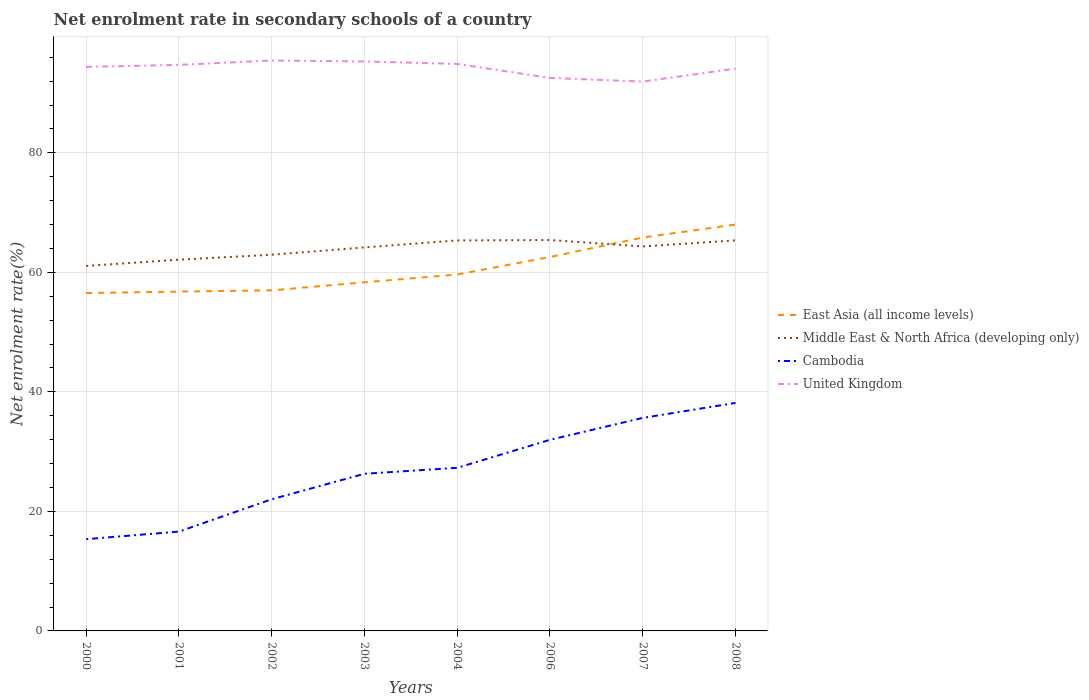How many different coloured lines are there?
Offer a terse response. 4. Across all years, what is the maximum net enrolment rate in secondary schools in Middle East & North Africa (developing only)?
Offer a terse response. 61.07. In which year was the net enrolment rate in secondary schools in Middle East & North Africa (developing only) maximum?
Keep it short and to the point. 2000. What is the total net enrolment rate in secondary schools in Middle East & North Africa (developing only) in the graph?
Provide a short and direct response. -3.24. What is the difference between the highest and the second highest net enrolment rate in secondary schools in Middle East & North Africa (developing only)?
Your response must be concise. 4.33. Is the net enrolment rate in secondary schools in Middle East & North Africa (developing only) strictly greater than the net enrolment rate in secondary schools in United Kingdom over the years?
Provide a short and direct response. Yes. Are the values on the major ticks of Y-axis written in scientific E-notation?
Your answer should be compact. No. Does the graph contain any zero values?
Your answer should be compact. No. Does the graph contain grids?
Your response must be concise. Yes. How many legend labels are there?
Offer a very short reply. 4. What is the title of the graph?
Keep it short and to the point. Net enrolment rate in secondary schools of a country. What is the label or title of the Y-axis?
Your response must be concise. Net enrolment rate(%). What is the Net enrolment rate(%) in East Asia (all income levels) in 2000?
Make the answer very short. 56.54. What is the Net enrolment rate(%) in Middle East & North Africa (developing only) in 2000?
Offer a terse response. 61.07. What is the Net enrolment rate(%) of Cambodia in 2000?
Make the answer very short. 15.36. What is the Net enrolment rate(%) in United Kingdom in 2000?
Make the answer very short. 94.38. What is the Net enrolment rate(%) in East Asia (all income levels) in 2001?
Provide a short and direct response. 56.78. What is the Net enrolment rate(%) of Middle East & North Africa (developing only) in 2001?
Your response must be concise. 62.12. What is the Net enrolment rate(%) in Cambodia in 2001?
Provide a short and direct response. 16.62. What is the Net enrolment rate(%) in United Kingdom in 2001?
Give a very brief answer. 94.72. What is the Net enrolment rate(%) of East Asia (all income levels) in 2002?
Make the answer very short. 56.99. What is the Net enrolment rate(%) of Middle East & North Africa (developing only) in 2002?
Make the answer very short. 62.95. What is the Net enrolment rate(%) in Cambodia in 2002?
Your answer should be compact. 22.03. What is the Net enrolment rate(%) of United Kingdom in 2002?
Offer a very short reply. 95.45. What is the Net enrolment rate(%) of East Asia (all income levels) in 2003?
Offer a terse response. 58.34. What is the Net enrolment rate(%) in Middle East & North Africa (developing only) in 2003?
Your answer should be compact. 64.17. What is the Net enrolment rate(%) of Cambodia in 2003?
Give a very brief answer. 26.3. What is the Net enrolment rate(%) of United Kingdom in 2003?
Your answer should be compact. 95.29. What is the Net enrolment rate(%) of East Asia (all income levels) in 2004?
Offer a terse response. 59.64. What is the Net enrolment rate(%) in Middle East & North Africa (developing only) in 2004?
Provide a succinct answer. 65.34. What is the Net enrolment rate(%) of Cambodia in 2004?
Your response must be concise. 27.29. What is the Net enrolment rate(%) in United Kingdom in 2004?
Give a very brief answer. 94.88. What is the Net enrolment rate(%) in East Asia (all income levels) in 2006?
Your answer should be compact. 62.57. What is the Net enrolment rate(%) of Middle East & North Africa (developing only) in 2006?
Provide a short and direct response. 65.41. What is the Net enrolment rate(%) in Cambodia in 2006?
Keep it short and to the point. 31.98. What is the Net enrolment rate(%) of United Kingdom in 2006?
Offer a terse response. 92.54. What is the Net enrolment rate(%) in East Asia (all income levels) in 2007?
Offer a very short reply. 65.83. What is the Net enrolment rate(%) in Middle East & North Africa (developing only) in 2007?
Your answer should be very brief. 64.34. What is the Net enrolment rate(%) of Cambodia in 2007?
Give a very brief answer. 35.65. What is the Net enrolment rate(%) in United Kingdom in 2007?
Provide a succinct answer. 91.92. What is the Net enrolment rate(%) in East Asia (all income levels) in 2008?
Keep it short and to the point. 68. What is the Net enrolment rate(%) of Middle East & North Africa (developing only) in 2008?
Offer a terse response. 65.36. What is the Net enrolment rate(%) in Cambodia in 2008?
Offer a terse response. 38.15. What is the Net enrolment rate(%) of United Kingdom in 2008?
Offer a terse response. 94.1. Across all years, what is the maximum Net enrolment rate(%) of East Asia (all income levels)?
Make the answer very short. 68. Across all years, what is the maximum Net enrolment rate(%) of Middle East & North Africa (developing only)?
Your answer should be very brief. 65.41. Across all years, what is the maximum Net enrolment rate(%) of Cambodia?
Keep it short and to the point. 38.15. Across all years, what is the maximum Net enrolment rate(%) of United Kingdom?
Your answer should be very brief. 95.45. Across all years, what is the minimum Net enrolment rate(%) of East Asia (all income levels)?
Keep it short and to the point. 56.54. Across all years, what is the minimum Net enrolment rate(%) in Middle East & North Africa (developing only)?
Offer a terse response. 61.07. Across all years, what is the minimum Net enrolment rate(%) of Cambodia?
Your response must be concise. 15.36. Across all years, what is the minimum Net enrolment rate(%) in United Kingdom?
Provide a short and direct response. 91.92. What is the total Net enrolment rate(%) in East Asia (all income levels) in the graph?
Offer a terse response. 484.7. What is the total Net enrolment rate(%) in Middle East & North Africa (developing only) in the graph?
Make the answer very short. 510.76. What is the total Net enrolment rate(%) in Cambodia in the graph?
Your answer should be very brief. 213.38. What is the total Net enrolment rate(%) of United Kingdom in the graph?
Offer a very short reply. 753.28. What is the difference between the Net enrolment rate(%) in East Asia (all income levels) in 2000 and that in 2001?
Your answer should be compact. -0.24. What is the difference between the Net enrolment rate(%) of Middle East & North Africa (developing only) in 2000 and that in 2001?
Provide a succinct answer. -1.04. What is the difference between the Net enrolment rate(%) of Cambodia in 2000 and that in 2001?
Offer a terse response. -1.27. What is the difference between the Net enrolment rate(%) of United Kingdom in 2000 and that in 2001?
Give a very brief answer. -0.34. What is the difference between the Net enrolment rate(%) in East Asia (all income levels) in 2000 and that in 2002?
Your response must be concise. -0.45. What is the difference between the Net enrolment rate(%) of Middle East & North Africa (developing only) in 2000 and that in 2002?
Offer a terse response. -1.88. What is the difference between the Net enrolment rate(%) of Cambodia in 2000 and that in 2002?
Ensure brevity in your answer.  -6.67. What is the difference between the Net enrolment rate(%) of United Kingdom in 2000 and that in 2002?
Make the answer very short. -1.07. What is the difference between the Net enrolment rate(%) of East Asia (all income levels) in 2000 and that in 2003?
Offer a very short reply. -1.8. What is the difference between the Net enrolment rate(%) of Middle East & North Africa (developing only) in 2000 and that in 2003?
Provide a succinct answer. -3.1. What is the difference between the Net enrolment rate(%) of Cambodia in 2000 and that in 2003?
Give a very brief answer. -10.94. What is the difference between the Net enrolment rate(%) of United Kingdom in 2000 and that in 2003?
Keep it short and to the point. -0.91. What is the difference between the Net enrolment rate(%) of East Asia (all income levels) in 2000 and that in 2004?
Provide a succinct answer. -3.1. What is the difference between the Net enrolment rate(%) of Middle East & North Africa (developing only) in 2000 and that in 2004?
Make the answer very short. -4.27. What is the difference between the Net enrolment rate(%) in Cambodia in 2000 and that in 2004?
Keep it short and to the point. -11.94. What is the difference between the Net enrolment rate(%) of United Kingdom in 2000 and that in 2004?
Provide a short and direct response. -0.5. What is the difference between the Net enrolment rate(%) of East Asia (all income levels) in 2000 and that in 2006?
Your answer should be compact. -6.03. What is the difference between the Net enrolment rate(%) of Middle East & North Africa (developing only) in 2000 and that in 2006?
Offer a very short reply. -4.33. What is the difference between the Net enrolment rate(%) of Cambodia in 2000 and that in 2006?
Ensure brevity in your answer.  -16.63. What is the difference between the Net enrolment rate(%) of United Kingdom in 2000 and that in 2006?
Give a very brief answer. 1.85. What is the difference between the Net enrolment rate(%) in East Asia (all income levels) in 2000 and that in 2007?
Provide a succinct answer. -9.29. What is the difference between the Net enrolment rate(%) of Middle East & North Africa (developing only) in 2000 and that in 2007?
Your response must be concise. -3.26. What is the difference between the Net enrolment rate(%) in Cambodia in 2000 and that in 2007?
Offer a terse response. -20.29. What is the difference between the Net enrolment rate(%) in United Kingdom in 2000 and that in 2007?
Give a very brief answer. 2.46. What is the difference between the Net enrolment rate(%) in East Asia (all income levels) in 2000 and that in 2008?
Give a very brief answer. -11.46. What is the difference between the Net enrolment rate(%) of Middle East & North Africa (developing only) in 2000 and that in 2008?
Your answer should be compact. -4.28. What is the difference between the Net enrolment rate(%) in Cambodia in 2000 and that in 2008?
Make the answer very short. -22.8. What is the difference between the Net enrolment rate(%) in United Kingdom in 2000 and that in 2008?
Keep it short and to the point. 0.28. What is the difference between the Net enrolment rate(%) in East Asia (all income levels) in 2001 and that in 2002?
Your answer should be compact. -0.21. What is the difference between the Net enrolment rate(%) in Middle East & North Africa (developing only) in 2001 and that in 2002?
Your response must be concise. -0.83. What is the difference between the Net enrolment rate(%) of Cambodia in 2001 and that in 2002?
Give a very brief answer. -5.41. What is the difference between the Net enrolment rate(%) in United Kingdom in 2001 and that in 2002?
Offer a terse response. -0.73. What is the difference between the Net enrolment rate(%) in East Asia (all income levels) in 2001 and that in 2003?
Your answer should be compact. -1.55. What is the difference between the Net enrolment rate(%) of Middle East & North Africa (developing only) in 2001 and that in 2003?
Give a very brief answer. -2.05. What is the difference between the Net enrolment rate(%) of Cambodia in 2001 and that in 2003?
Provide a succinct answer. -9.67. What is the difference between the Net enrolment rate(%) in United Kingdom in 2001 and that in 2003?
Your response must be concise. -0.58. What is the difference between the Net enrolment rate(%) of East Asia (all income levels) in 2001 and that in 2004?
Ensure brevity in your answer.  -2.86. What is the difference between the Net enrolment rate(%) in Middle East & North Africa (developing only) in 2001 and that in 2004?
Your answer should be compact. -3.22. What is the difference between the Net enrolment rate(%) in Cambodia in 2001 and that in 2004?
Offer a terse response. -10.67. What is the difference between the Net enrolment rate(%) of United Kingdom in 2001 and that in 2004?
Provide a short and direct response. -0.17. What is the difference between the Net enrolment rate(%) in East Asia (all income levels) in 2001 and that in 2006?
Your response must be concise. -5.79. What is the difference between the Net enrolment rate(%) in Middle East & North Africa (developing only) in 2001 and that in 2006?
Provide a short and direct response. -3.29. What is the difference between the Net enrolment rate(%) of Cambodia in 2001 and that in 2006?
Make the answer very short. -15.36. What is the difference between the Net enrolment rate(%) of United Kingdom in 2001 and that in 2006?
Make the answer very short. 2.18. What is the difference between the Net enrolment rate(%) of East Asia (all income levels) in 2001 and that in 2007?
Your answer should be compact. -9.05. What is the difference between the Net enrolment rate(%) of Middle East & North Africa (developing only) in 2001 and that in 2007?
Ensure brevity in your answer.  -2.22. What is the difference between the Net enrolment rate(%) of Cambodia in 2001 and that in 2007?
Your answer should be compact. -19.02. What is the difference between the Net enrolment rate(%) in United Kingdom in 2001 and that in 2007?
Provide a short and direct response. 2.8. What is the difference between the Net enrolment rate(%) of East Asia (all income levels) in 2001 and that in 2008?
Your answer should be very brief. -11.22. What is the difference between the Net enrolment rate(%) in Middle East & North Africa (developing only) in 2001 and that in 2008?
Give a very brief answer. -3.24. What is the difference between the Net enrolment rate(%) of Cambodia in 2001 and that in 2008?
Ensure brevity in your answer.  -21.53. What is the difference between the Net enrolment rate(%) in United Kingdom in 2001 and that in 2008?
Make the answer very short. 0.62. What is the difference between the Net enrolment rate(%) of East Asia (all income levels) in 2002 and that in 2003?
Your response must be concise. -1.35. What is the difference between the Net enrolment rate(%) in Middle East & North Africa (developing only) in 2002 and that in 2003?
Offer a terse response. -1.22. What is the difference between the Net enrolment rate(%) in Cambodia in 2002 and that in 2003?
Your response must be concise. -4.27. What is the difference between the Net enrolment rate(%) of United Kingdom in 2002 and that in 2003?
Provide a short and direct response. 0.16. What is the difference between the Net enrolment rate(%) of East Asia (all income levels) in 2002 and that in 2004?
Make the answer very short. -2.65. What is the difference between the Net enrolment rate(%) in Middle East & North Africa (developing only) in 2002 and that in 2004?
Give a very brief answer. -2.39. What is the difference between the Net enrolment rate(%) in Cambodia in 2002 and that in 2004?
Your response must be concise. -5.26. What is the difference between the Net enrolment rate(%) in United Kingdom in 2002 and that in 2004?
Make the answer very short. 0.57. What is the difference between the Net enrolment rate(%) of East Asia (all income levels) in 2002 and that in 2006?
Provide a short and direct response. -5.58. What is the difference between the Net enrolment rate(%) of Middle East & North Africa (developing only) in 2002 and that in 2006?
Give a very brief answer. -2.46. What is the difference between the Net enrolment rate(%) in Cambodia in 2002 and that in 2006?
Offer a very short reply. -9.95. What is the difference between the Net enrolment rate(%) in United Kingdom in 2002 and that in 2006?
Ensure brevity in your answer.  2.91. What is the difference between the Net enrolment rate(%) of East Asia (all income levels) in 2002 and that in 2007?
Offer a terse response. -8.84. What is the difference between the Net enrolment rate(%) of Middle East & North Africa (developing only) in 2002 and that in 2007?
Give a very brief answer. -1.38. What is the difference between the Net enrolment rate(%) in Cambodia in 2002 and that in 2007?
Keep it short and to the point. -13.62. What is the difference between the Net enrolment rate(%) of United Kingdom in 2002 and that in 2007?
Your answer should be compact. 3.53. What is the difference between the Net enrolment rate(%) in East Asia (all income levels) in 2002 and that in 2008?
Your answer should be very brief. -11.01. What is the difference between the Net enrolment rate(%) in Middle East & North Africa (developing only) in 2002 and that in 2008?
Give a very brief answer. -2.4. What is the difference between the Net enrolment rate(%) of Cambodia in 2002 and that in 2008?
Your response must be concise. -16.12. What is the difference between the Net enrolment rate(%) in United Kingdom in 2002 and that in 2008?
Your response must be concise. 1.35. What is the difference between the Net enrolment rate(%) of East Asia (all income levels) in 2003 and that in 2004?
Give a very brief answer. -1.3. What is the difference between the Net enrolment rate(%) of Middle East & North Africa (developing only) in 2003 and that in 2004?
Your answer should be very brief. -1.17. What is the difference between the Net enrolment rate(%) of Cambodia in 2003 and that in 2004?
Keep it short and to the point. -1. What is the difference between the Net enrolment rate(%) of United Kingdom in 2003 and that in 2004?
Your response must be concise. 0.41. What is the difference between the Net enrolment rate(%) in East Asia (all income levels) in 2003 and that in 2006?
Your answer should be very brief. -4.23. What is the difference between the Net enrolment rate(%) in Middle East & North Africa (developing only) in 2003 and that in 2006?
Your answer should be compact. -1.24. What is the difference between the Net enrolment rate(%) of Cambodia in 2003 and that in 2006?
Provide a succinct answer. -5.69. What is the difference between the Net enrolment rate(%) of United Kingdom in 2003 and that in 2006?
Your answer should be very brief. 2.76. What is the difference between the Net enrolment rate(%) in East Asia (all income levels) in 2003 and that in 2007?
Offer a terse response. -7.49. What is the difference between the Net enrolment rate(%) of Middle East & North Africa (developing only) in 2003 and that in 2007?
Your answer should be very brief. -0.16. What is the difference between the Net enrolment rate(%) in Cambodia in 2003 and that in 2007?
Provide a succinct answer. -9.35. What is the difference between the Net enrolment rate(%) of United Kingdom in 2003 and that in 2007?
Your answer should be compact. 3.37. What is the difference between the Net enrolment rate(%) in East Asia (all income levels) in 2003 and that in 2008?
Provide a short and direct response. -9.66. What is the difference between the Net enrolment rate(%) in Middle East & North Africa (developing only) in 2003 and that in 2008?
Ensure brevity in your answer.  -1.18. What is the difference between the Net enrolment rate(%) in Cambodia in 2003 and that in 2008?
Your answer should be compact. -11.86. What is the difference between the Net enrolment rate(%) in United Kingdom in 2003 and that in 2008?
Your answer should be very brief. 1.2. What is the difference between the Net enrolment rate(%) in East Asia (all income levels) in 2004 and that in 2006?
Make the answer very short. -2.93. What is the difference between the Net enrolment rate(%) in Middle East & North Africa (developing only) in 2004 and that in 2006?
Your answer should be very brief. -0.06. What is the difference between the Net enrolment rate(%) in Cambodia in 2004 and that in 2006?
Offer a very short reply. -4.69. What is the difference between the Net enrolment rate(%) in United Kingdom in 2004 and that in 2006?
Provide a short and direct response. 2.35. What is the difference between the Net enrolment rate(%) in East Asia (all income levels) in 2004 and that in 2007?
Provide a short and direct response. -6.19. What is the difference between the Net enrolment rate(%) of Middle East & North Africa (developing only) in 2004 and that in 2007?
Keep it short and to the point. 1.01. What is the difference between the Net enrolment rate(%) of Cambodia in 2004 and that in 2007?
Your answer should be compact. -8.35. What is the difference between the Net enrolment rate(%) in United Kingdom in 2004 and that in 2007?
Your answer should be compact. 2.96. What is the difference between the Net enrolment rate(%) of East Asia (all income levels) in 2004 and that in 2008?
Offer a very short reply. -8.36. What is the difference between the Net enrolment rate(%) of Middle East & North Africa (developing only) in 2004 and that in 2008?
Offer a very short reply. -0.01. What is the difference between the Net enrolment rate(%) in Cambodia in 2004 and that in 2008?
Give a very brief answer. -10.86. What is the difference between the Net enrolment rate(%) in United Kingdom in 2004 and that in 2008?
Provide a short and direct response. 0.79. What is the difference between the Net enrolment rate(%) in East Asia (all income levels) in 2006 and that in 2007?
Offer a very short reply. -3.26. What is the difference between the Net enrolment rate(%) in Middle East & North Africa (developing only) in 2006 and that in 2007?
Make the answer very short. 1.07. What is the difference between the Net enrolment rate(%) of Cambodia in 2006 and that in 2007?
Provide a short and direct response. -3.66. What is the difference between the Net enrolment rate(%) of United Kingdom in 2006 and that in 2007?
Provide a succinct answer. 0.62. What is the difference between the Net enrolment rate(%) of East Asia (all income levels) in 2006 and that in 2008?
Keep it short and to the point. -5.43. What is the difference between the Net enrolment rate(%) in Middle East & North Africa (developing only) in 2006 and that in 2008?
Offer a terse response. 0.05. What is the difference between the Net enrolment rate(%) in Cambodia in 2006 and that in 2008?
Offer a very short reply. -6.17. What is the difference between the Net enrolment rate(%) of United Kingdom in 2006 and that in 2008?
Offer a very short reply. -1.56. What is the difference between the Net enrolment rate(%) of East Asia (all income levels) in 2007 and that in 2008?
Provide a short and direct response. -2.17. What is the difference between the Net enrolment rate(%) in Middle East & North Africa (developing only) in 2007 and that in 2008?
Your answer should be compact. -1.02. What is the difference between the Net enrolment rate(%) in Cambodia in 2007 and that in 2008?
Your answer should be compact. -2.51. What is the difference between the Net enrolment rate(%) of United Kingdom in 2007 and that in 2008?
Make the answer very short. -2.18. What is the difference between the Net enrolment rate(%) of East Asia (all income levels) in 2000 and the Net enrolment rate(%) of Middle East & North Africa (developing only) in 2001?
Your answer should be compact. -5.58. What is the difference between the Net enrolment rate(%) in East Asia (all income levels) in 2000 and the Net enrolment rate(%) in Cambodia in 2001?
Make the answer very short. 39.92. What is the difference between the Net enrolment rate(%) of East Asia (all income levels) in 2000 and the Net enrolment rate(%) of United Kingdom in 2001?
Offer a very short reply. -38.18. What is the difference between the Net enrolment rate(%) in Middle East & North Africa (developing only) in 2000 and the Net enrolment rate(%) in Cambodia in 2001?
Your answer should be compact. 44.45. What is the difference between the Net enrolment rate(%) in Middle East & North Africa (developing only) in 2000 and the Net enrolment rate(%) in United Kingdom in 2001?
Make the answer very short. -33.64. What is the difference between the Net enrolment rate(%) in Cambodia in 2000 and the Net enrolment rate(%) in United Kingdom in 2001?
Make the answer very short. -79.36. What is the difference between the Net enrolment rate(%) in East Asia (all income levels) in 2000 and the Net enrolment rate(%) in Middle East & North Africa (developing only) in 2002?
Offer a terse response. -6.41. What is the difference between the Net enrolment rate(%) in East Asia (all income levels) in 2000 and the Net enrolment rate(%) in Cambodia in 2002?
Your response must be concise. 34.51. What is the difference between the Net enrolment rate(%) of East Asia (all income levels) in 2000 and the Net enrolment rate(%) of United Kingdom in 2002?
Give a very brief answer. -38.91. What is the difference between the Net enrolment rate(%) of Middle East & North Africa (developing only) in 2000 and the Net enrolment rate(%) of Cambodia in 2002?
Give a very brief answer. 39.04. What is the difference between the Net enrolment rate(%) of Middle East & North Africa (developing only) in 2000 and the Net enrolment rate(%) of United Kingdom in 2002?
Offer a very short reply. -34.38. What is the difference between the Net enrolment rate(%) of Cambodia in 2000 and the Net enrolment rate(%) of United Kingdom in 2002?
Your answer should be very brief. -80.09. What is the difference between the Net enrolment rate(%) in East Asia (all income levels) in 2000 and the Net enrolment rate(%) in Middle East & North Africa (developing only) in 2003?
Make the answer very short. -7.63. What is the difference between the Net enrolment rate(%) of East Asia (all income levels) in 2000 and the Net enrolment rate(%) of Cambodia in 2003?
Your answer should be very brief. 30.24. What is the difference between the Net enrolment rate(%) of East Asia (all income levels) in 2000 and the Net enrolment rate(%) of United Kingdom in 2003?
Provide a short and direct response. -38.75. What is the difference between the Net enrolment rate(%) in Middle East & North Africa (developing only) in 2000 and the Net enrolment rate(%) in Cambodia in 2003?
Make the answer very short. 34.78. What is the difference between the Net enrolment rate(%) of Middle East & North Africa (developing only) in 2000 and the Net enrolment rate(%) of United Kingdom in 2003?
Keep it short and to the point. -34.22. What is the difference between the Net enrolment rate(%) of Cambodia in 2000 and the Net enrolment rate(%) of United Kingdom in 2003?
Give a very brief answer. -79.94. What is the difference between the Net enrolment rate(%) in East Asia (all income levels) in 2000 and the Net enrolment rate(%) in Middle East & North Africa (developing only) in 2004?
Provide a short and direct response. -8.8. What is the difference between the Net enrolment rate(%) of East Asia (all income levels) in 2000 and the Net enrolment rate(%) of Cambodia in 2004?
Your answer should be very brief. 29.25. What is the difference between the Net enrolment rate(%) of East Asia (all income levels) in 2000 and the Net enrolment rate(%) of United Kingdom in 2004?
Offer a very short reply. -38.34. What is the difference between the Net enrolment rate(%) of Middle East & North Africa (developing only) in 2000 and the Net enrolment rate(%) of Cambodia in 2004?
Your answer should be very brief. 33.78. What is the difference between the Net enrolment rate(%) in Middle East & North Africa (developing only) in 2000 and the Net enrolment rate(%) in United Kingdom in 2004?
Your answer should be very brief. -33.81. What is the difference between the Net enrolment rate(%) of Cambodia in 2000 and the Net enrolment rate(%) of United Kingdom in 2004?
Make the answer very short. -79.53. What is the difference between the Net enrolment rate(%) in East Asia (all income levels) in 2000 and the Net enrolment rate(%) in Middle East & North Africa (developing only) in 2006?
Ensure brevity in your answer.  -8.87. What is the difference between the Net enrolment rate(%) in East Asia (all income levels) in 2000 and the Net enrolment rate(%) in Cambodia in 2006?
Your response must be concise. 24.56. What is the difference between the Net enrolment rate(%) of East Asia (all income levels) in 2000 and the Net enrolment rate(%) of United Kingdom in 2006?
Offer a very short reply. -36. What is the difference between the Net enrolment rate(%) of Middle East & North Africa (developing only) in 2000 and the Net enrolment rate(%) of Cambodia in 2006?
Offer a terse response. 29.09. What is the difference between the Net enrolment rate(%) of Middle East & North Africa (developing only) in 2000 and the Net enrolment rate(%) of United Kingdom in 2006?
Your response must be concise. -31.46. What is the difference between the Net enrolment rate(%) of Cambodia in 2000 and the Net enrolment rate(%) of United Kingdom in 2006?
Offer a very short reply. -77.18. What is the difference between the Net enrolment rate(%) of East Asia (all income levels) in 2000 and the Net enrolment rate(%) of Middle East & North Africa (developing only) in 2007?
Your answer should be very brief. -7.8. What is the difference between the Net enrolment rate(%) in East Asia (all income levels) in 2000 and the Net enrolment rate(%) in Cambodia in 2007?
Make the answer very short. 20.9. What is the difference between the Net enrolment rate(%) of East Asia (all income levels) in 2000 and the Net enrolment rate(%) of United Kingdom in 2007?
Ensure brevity in your answer.  -35.38. What is the difference between the Net enrolment rate(%) in Middle East & North Africa (developing only) in 2000 and the Net enrolment rate(%) in Cambodia in 2007?
Give a very brief answer. 25.43. What is the difference between the Net enrolment rate(%) of Middle East & North Africa (developing only) in 2000 and the Net enrolment rate(%) of United Kingdom in 2007?
Offer a very short reply. -30.85. What is the difference between the Net enrolment rate(%) of Cambodia in 2000 and the Net enrolment rate(%) of United Kingdom in 2007?
Keep it short and to the point. -76.56. What is the difference between the Net enrolment rate(%) of East Asia (all income levels) in 2000 and the Net enrolment rate(%) of Middle East & North Africa (developing only) in 2008?
Your answer should be compact. -8.81. What is the difference between the Net enrolment rate(%) of East Asia (all income levels) in 2000 and the Net enrolment rate(%) of Cambodia in 2008?
Your answer should be very brief. 18.39. What is the difference between the Net enrolment rate(%) of East Asia (all income levels) in 2000 and the Net enrolment rate(%) of United Kingdom in 2008?
Your answer should be compact. -37.56. What is the difference between the Net enrolment rate(%) in Middle East & North Africa (developing only) in 2000 and the Net enrolment rate(%) in Cambodia in 2008?
Offer a very short reply. 22.92. What is the difference between the Net enrolment rate(%) of Middle East & North Africa (developing only) in 2000 and the Net enrolment rate(%) of United Kingdom in 2008?
Provide a succinct answer. -33.02. What is the difference between the Net enrolment rate(%) in Cambodia in 2000 and the Net enrolment rate(%) in United Kingdom in 2008?
Offer a terse response. -78.74. What is the difference between the Net enrolment rate(%) of East Asia (all income levels) in 2001 and the Net enrolment rate(%) of Middle East & North Africa (developing only) in 2002?
Your answer should be compact. -6.17. What is the difference between the Net enrolment rate(%) of East Asia (all income levels) in 2001 and the Net enrolment rate(%) of Cambodia in 2002?
Ensure brevity in your answer.  34.75. What is the difference between the Net enrolment rate(%) in East Asia (all income levels) in 2001 and the Net enrolment rate(%) in United Kingdom in 2002?
Offer a terse response. -38.67. What is the difference between the Net enrolment rate(%) in Middle East & North Africa (developing only) in 2001 and the Net enrolment rate(%) in Cambodia in 2002?
Your answer should be compact. 40.09. What is the difference between the Net enrolment rate(%) of Middle East & North Africa (developing only) in 2001 and the Net enrolment rate(%) of United Kingdom in 2002?
Provide a succinct answer. -33.33. What is the difference between the Net enrolment rate(%) of Cambodia in 2001 and the Net enrolment rate(%) of United Kingdom in 2002?
Offer a very short reply. -78.83. What is the difference between the Net enrolment rate(%) in East Asia (all income levels) in 2001 and the Net enrolment rate(%) in Middle East & North Africa (developing only) in 2003?
Offer a very short reply. -7.39. What is the difference between the Net enrolment rate(%) in East Asia (all income levels) in 2001 and the Net enrolment rate(%) in Cambodia in 2003?
Ensure brevity in your answer.  30.49. What is the difference between the Net enrolment rate(%) in East Asia (all income levels) in 2001 and the Net enrolment rate(%) in United Kingdom in 2003?
Provide a short and direct response. -38.51. What is the difference between the Net enrolment rate(%) of Middle East & North Africa (developing only) in 2001 and the Net enrolment rate(%) of Cambodia in 2003?
Make the answer very short. 35.82. What is the difference between the Net enrolment rate(%) in Middle East & North Africa (developing only) in 2001 and the Net enrolment rate(%) in United Kingdom in 2003?
Offer a terse response. -33.17. What is the difference between the Net enrolment rate(%) of Cambodia in 2001 and the Net enrolment rate(%) of United Kingdom in 2003?
Your answer should be very brief. -78.67. What is the difference between the Net enrolment rate(%) of East Asia (all income levels) in 2001 and the Net enrolment rate(%) of Middle East & North Africa (developing only) in 2004?
Give a very brief answer. -8.56. What is the difference between the Net enrolment rate(%) of East Asia (all income levels) in 2001 and the Net enrolment rate(%) of Cambodia in 2004?
Your answer should be compact. 29.49. What is the difference between the Net enrolment rate(%) of East Asia (all income levels) in 2001 and the Net enrolment rate(%) of United Kingdom in 2004?
Offer a very short reply. -38.1. What is the difference between the Net enrolment rate(%) in Middle East & North Africa (developing only) in 2001 and the Net enrolment rate(%) in Cambodia in 2004?
Provide a short and direct response. 34.82. What is the difference between the Net enrolment rate(%) of Middle East & North Africa (developing only) in 2001 and the Net enrolment rate(%) of United Kingdom in 2004?
Ensure brevity in your answer.  -32.76. What is the difference between the Net enrolment rate(%) of Cambodia in 2001 and the Net enrolment rate(%) of United Kingdom in 2004?
Give a very brief answer. -78.26. What is the difference between the Net enrolment rate(%) of East Asia (all income levels) in 2001 and the Net enrolment rate(%) of Middle East & North Africa (developing only) in 2006?
Your response must be concise. -8.63. What is the difference between the Net enrolment rate(%) in East Asia (all income levels) in 2001 and the Net enrolment rate(%) in Cambodia in 2006?
Offer a very short reply. 24.8. What is the difference between the Net enrolment rate(%) in East Asia (all income levels) in 2001 and the Net enrolment rate(%) in United Kingdom in 2006?
Your answer should be compact. -35.76. What is the difference between the Net enrolment rate(%) in Middle East & North Africa (developing only) in 2001 and the Net enrolment rate(%) in Cambodia in 2006?
Ensure brevity in your answer.  30.14. What is the difference between the Net enrolment rate(%) of Middle East & North Africa (developing only) in 2001 and the Net enrolment rate(%) of United Kingdom in 2006?
Provide a short and direct response. -30.42. What is the difference between the Net enrolment rate(%) of Cambodia in 2001 and the Net enrolment rate(%) of United Kingdom in 2006?
Your response must be concise. -75.91. What is the difference between the Net enrolment rate(%) in East Asia (all income levels) in 2001 and the Net enrolment rate(%) in Middle East & North Africa (developing only) in 2007?
Provide a short and direct response. -7.55. What is the difference between the Net enrolment rate(%) in East Asia (all income levels) in 2001 and the Net enrolment rate(%) in Cambodia in 2007?
Offer a very short reply. 21.14. What is the difference between the Net enrolment rate(%) of East Asia (all income levels) in 2001 and the Net enrolment rate(%) of United Kingdom in 2007?
Offer a very short reply. -35.14. What is the difference between the Net enrolment rate(%) in Middle East & North Africa (developing only) in 2001 and the Net enrolment rate(%) in Cambodia in 2007?
Give a very brief answer. 26.47. What is the difference between the Net enrolment rate(%) of Middle East & North Africa (developing only) in 2001 and the Net enrolment rate(%) of United Kingdom in 2007?
Ensure brevity in your answer.  -29.8. What is the difference between the Net enrolment rate(%) of Cambodia in 2001 and the Net enrolment rate(%) of United Kingdom in 2007?
Your answer should be compact. -75.3. What is the difference between the Net enrolment rate(%) of East Asia (all income levels) in 2001 and the Net enrolment rate(%) of Middle East & North Africa (developing only) in 2008?
Make the answer very short. -8.57. What is the difference between the Net enrolment rate(%) of East Asia (all income levels) in 2001 and the Net enrolment rate(%) of Cambodia in 2008?
Your answer should be very brief. 18.63. What is the difference between the Net enrolment rate(%) of East Asia (all income levels) in 2001 and the Net enrolment rate(%) of United Kingdom in 2008?
Offer a very short reply. -37.32. What is the difference between the Net enrolment rate(%) of Middle East & North Africa (developing only) in 2001 and the Net enrolment rate(%) of Cambodia in 2008?
Give a very brief answer. 23.97. What is the difference between the Net enrolment rate(%) in Middle East & North Africa (developing only) in 2001 and the Net enrolment rate(%) in United Kingdom in 2008?
Provide a succinct answer. -31.98. What is the difference between the Net enrolment rate(%) in Cambodia in 2001 and the Net enrolment rate(%) in United Kingdom in 2008?
Provide a succinct answer. -77.48. What is the difference between the Net enrolment rate(%) in East Asia (all income levels) in 2002 and the Net enrolment rate(%) in Middle East & North Africa (developing only) in 2003?
Offer a very short reply. -7.18. What is the difference between the Net enrolment rate(%) of East Asia (all income levels) in 2002 and the Net enrolment rate(%) of Cambodia in 2003?
Provide a succinct answer. 30.69. What is the difference between the Net enrolment rate(%) of East Asia (all income levels) in 2002 and the Net enrolment rate(%) of United Kingdom in 2003?
Your answer should be very brief. -38.3. What is the difference between the Net enrolment rate(%) of Middle East & North Africa (developing only) in 2002 and the Net enrolment rate(%) of Cambodia in 2003?
Give a very brief answer. 36.66. What is the difference between the Net enrolment rate(%) in Middle East & North Africa (developing only) in 2002 and the Net enrolment rate(%) in United Kingdom in 2003?
Your response must be concise. -32.34. What is the difference between the Net enrolment rate(%) in Cambodia in 2002 and the Net enrolment rate(%) in United Kingdom in 2003?
Provide a short and direct response. -73.26. What is the difference between the Net enrolment rate(%) in East Asia (all income levels) in 2002 and the Net enrolment rate(%) in Middle East & North Africa (developing only) in 2004?
Your response must be concise. -8.35. What is the difference between the Net enrolment rate(%) of East Asia (all income levels) in 2002 and the Net enrolment rate(%) of Cambodia in 2004?
Your response must be concise. 29.7. What is the difference between the Net enrolment rate(%) of East Asia (all income levels) in 2002 and the Net enrolment rate(%) of United Kingdom in 2004?
Offer a terse response. -37.89. What is the difference between the Net enrolment rate(%) in Middle East & North Africa (developing only) in 2002 and the Net enrolment rate(%) in Cambodia in 2004?
Offer a very short reply. 35.66. What is the difference between the Net enrolment rate(%) in Middle East & North Africa (developing only) in 2002 and the Net enrolment rate(%) in United Kingdom in 2004?
Your answer should be very brief. -31.93. What is the difference between the Net enrolment rate(%) in Cambodia in 2002 and the Net enrolment rate(%) in United Kingdom in 2004?
Your answer should be compact. -72.85. What is the difference between the Net enrolment rate(%) of East Asia (all income levels) in 2002 and the Net enrolment rate(%) of Middle East & North Africa (developing only) in 2006?
Your response must be concise. -8.42. What is the difference between the Net enrolment rate(%) in East Asia (all income levels) in 2002 and the Net enrolment rate(%) in Cambodia in 2006?
Your answer should be compact. 25.01. What is the difference between the Net enrolment rate(%) of East Asia (all income levels) in 2002 and the Net enrolment rate(%) of United Kingdom in 2006?
Your response must be concise. -35.55. What is the difference between the Net enrolment rate(%) in Middle East & North Africa (developing only) in 2002 and the Net enrolment rate(%) in Cambodia in 2006?
Ensure brevity in your answer.  30.97. What is the difference between the Net enrolment rate(%) of Middle East & North Africa (developing only) in 2002 and the Net enrolment rate(%) of United Kingdom in 2006?
Keep it short and to the point. -29.58. What is the difference between the Net enrolment rate(%) in Cambodia in 2002 and the Net enrolment rate(%) in United Kingdom in 2006?
Your answer should be very brief. -70.51. What is the difference between the Net enrolment rate(%) of East Asia (all income levels) in 2002 and the Net enrolment rate(%) of Middle East & North Africa (developing only) in 2007?
Ensure brevity in your answer.  -7.35. What is the difference between the Net enrolment rate(%) in East Asia (all income levels) in 2002 and the Net enrolment rate(%) in Cambodia in 2007?
Give a very brief answer. 21.34. What is the difference between the Net enrolment rate(%) in East Asia (all income levels) in 2002 and the Net enrolment rate(%) in United Kingdom in 2007?
Your response must be concise. -34.93. What is the difference between the Net enrolment rate(%) in Middle East & North Africa (developing only) in 2002 and the Net enrolment rate(%) in Cambodia in 2007?
Your response must be concise. 27.31. What is the difference between the Net enrolment rate(%) in Middle East & North Africa (developing only) in 2002 and the Net enrolment rate(%) in United Kingdom in 2007?
Give a very brief answer. -28.97. What is the difference between the Net enrolment rate(%) of Cambodia in 2002 and the Net enrolment rate(%) of United Kingdom in 2007?
Provide a succinct answer. -69.89. What is the difference between the Net enrolment rate(%) of East Asia (all income levels) in 2002 and the Net enrolment rate(%) of Middle East & North Africa (developing only) in 2008?
Your answer should be very brief. -8.37. What is the difference between the Net enrolment rate(%) of East Asia (all income levels) in 2002 and the Net enrolment rate(%) of Cambodia in 2008?
Provide a short and direct response. 18.84. What is the difference between the Net enrolment rate(%) of East Asia (all income levels) in 2002 and the Net enrolment rate(%) of United Kingdom in 2008?
Give a very brief answer. -37.11. What is the difference between the Net enrolment rate(%) of Middle East & North Africa (developing only) in 2002 and the Net enrolment rate(%) of Cambodia in 2008?
Make the answer very short. 24.8. What is the difference between the Net enrolment rate(%) in Middle East & North Africa (developing only) in 2002 and the Net enrolment rate(%) in United Kingdom in 2008?
Ensure brevity in your answer.  -31.15. What is the difference between the Net enrolment rate(%) in Cambodia in 2002 and the Net enrolment rate(%) in United Kingdom in 2008?
Keep it short and to the point. -72.07. What is the difference between the Net enrolment rate(%) of East Asia (all income levels) in 2003 and the Net enrolment rate(%) of Middle East & North Africa (developing only) in 2004?
Provide a short and direct response. -7.01. What is the difference between the Net enrolment rate(%) of East Asia (all income levels) in 2003 and the Net enrolment rate(%) of Cambodia in 2004?
Provide a short and direct response. 31.04. What is the difference between the Net enrolment rate(%) in East Asia (all income levels) in 2003 and the Net enrolment rate(%) in United Kingdom in 2004?
Provide a succinct answer. -36.55. What is the difference between the Net enrolment rate(%) in Middle East & North Africa (developing only) in 2003 and the Net enrolment rate(%) in Cambodia in 2004?
Offer a very short reply. 36.88. What is the difference between the Net enrolment rate(%) in Middle East & North Africa (developing only) in 2003 and the Net enrolment rate(%) in United Kingdom in 2004?
Give a very brief answer. -30.71. What is the difference between the Net enrolment rate(%) in Cambodia in 2003 and the Net enrolment rate(%) in United Kingdom in 2004?
Your answer should be very brief. -68.59. What is the difference between the Net enrolment rate(%) of East Asia (all income levels) in 2003 and the Net enrolment rate(%) of Middle East & North Africa (developing only) in 2006?
Your response must be concise. -7.07. What is the difference between the Net enrolment rate(%) of East Asia (all income levels) in 2003 and the Net enrolment rate(%) of Cambodia in 2006?
Offer a very short reply. 26.36. What is the difference between the Net enrolment rate(%) in East Asia (all income levels) in 2003 and the Net enrolment rate(%) in United Kingdom in 2006?
Your answer should be compact. -34.2. What is the difference between the Net enrolment rate(%) in Middle East & North Africa (developing only) in 2003 and the Net enrolment rate(%) in Cambodia in 2006?
Offer a very short reply. 32.19. What is the difference between the Net enrolment rate(%) of Middle East & North Africa (developing only) in 2003 and the Net enrolment rate(%) of United Kingdom in 2006?
Provide a short and direct response. -28.36. What is the difference between the Net enrolment rate(%) of Cambodia in 2003 and the Net enrolment rate(%) of United Kingdom in 2006?
Provide a short and direct response. -66.24. What is the difference between the Net enrolment rate(%) in East Asia (all income levels) in 2003 and the Net enrolment rate(%) in Middle East & North Africa (developing only) in 2007?
Your response must be concise. -6. What is the difference between the Net enrolment rate(%) in East Asia (all income levels) in 2003 and the Net enrolment rate(%) in Cambodia in 2007?
Provide a short and direct response. 22.69. What is the difference between the Net enrolment rate(%) of East Asia (all income levels) in 2003 and the Net enrolment rate(%) of United Kingdom in 2007?
Provide a short and direct response. -33.58. What is the difference between the Net enrolment rate(%) in Middle East & North Africa (developing only) in 2003 and the Net enrolment rate(%) in Cambodia in 2007?
Your response must be concise. 28.53. What is the difference between the Net enrolment rate(%) in Middle East & North Africa (developing only) in 2003 and the Net enrolment rate(%) in United Kingdom in 2007?
Provide a succinct answer. -27.75. What is the difference between the Net enrolment rate(%) of Cambodia in 2003 and the Net enrolment rate(%) of United Kingdom in 2007?
Give a very brief answer. -65.62. What is the difference between the Net enrolment rate(%) in East Asia (all income levels) in 2003 and the Net enrolment rate(%) in Middle East & North Africa (developing only) in 2008?
Give a very brief answer. -7.02. What is the difference between the Net enrolment rate(%) of East Asia (all income levels) in 2003 and the Net enrolment rate(%) of Cambodia in 2008?
Provide a succinct answer. 20.18. What is the difference between the Net enrolment rate(%) of East Asia (all income levels) in 2003 and the Net enrolment rate(%) of United Kingdom in 2008?
Make the answer very short. -35.76. What is the difference between the Net enrolment rate(%) in Middle East & North Africa (developing only) in 2003 and the Net enrolment rate(%) in Cambodia in 2008?
Offer a terse response. 26.02. What is the difference between the Net enrolment rate(%) in Middle East & North Africa (developing only) in 2003 and the Net enrolment rate(%) in United Kingdom in 2008?
Keep it short and to the point. -29.93. What is the difference between the Net enrolment rate(%) in Cambodia in 2003 and the Net enrolment rate(%) in United Kingdom in 2008?
Ensure brevity in your answer.  -67.8. What is the difference between the Net enrolment rate(%) of East Asia (all income levels) in 2004 and the Net enrolment rate(%) of Middle East & North Africa (developing only) in 2006?
Your response must be concise. -5.77. What is the difference between the Net enrolment rate(%) of East Asia (all income levels) in 2004 and the Net enrolment rate(%) of Cambodia in 2006?
Give a very brief answer. 27.66. What is the difference between the Net enrolment rate(%) of East Asia (all income levels) in 2004 and the Net enrolment rate(%) of United Kingdom in 2006?
Keep it short and to the point. -32.9. What is the difference between the Net enrolment rate(%) in Middle East & North Africa (developing only) in 2004 and the Net enrolment rate(%) in Cambodia in 2006?
Provide a succinct answer. 33.36. What is the difference between the Net enrolment rate(%) in Middle East & North Africa (developing only) in 2004 and the Net enrolment rate(%) in United Kingdom in 2006?
Your answer should be very brief. -27.19. What is the difference between the Net enrolment rate(%) in Cambodia in 2004 and the Net enrolment rate(%) in United Kingdom in 2006?
Provide a succinct answer. -65.24. What is the difference between the Net enrolment rate(%) in East Asia (all income levels) in 2004 and the Net enrolment rate(%) in Middle East & North Africa (developing only) in 2007?
Offer a very short reply. -4.7. What is the difference between the Net enrolment rate(%) in East Asia (all income levels) in 2004 and the Net enrolment rate(%) in Cambodia in 2007?
Keep it short and to the point. 23.99. What is the difference between the Net enrolment rate(%) of East Asia (all income levels) in 2004 and the Net enrolment rate(%) of United Kingdom in 2007?
Your answer should be compact. -32.28. What is the difference between the Net enrolment rate(%) of Middle East & North Africa (developing only) in 2004 and the Net enrolment rate(%) of Cambodia in 2007?
Ensure brevity in your answer.  29.7. What is the difference between the Net enrolment rate(%) of Middle East & North Africa (developing only) in 2004 and the Net enrolment rate(%) of United Kingdom in 2007?
Provide a short and direct response. -26.58. What is the difference between the Net enrolment rate(%) of Cambodia in 2004 and the Net enrolment rate(%) of United Kingdom in 2007?
Give a very brief answer. -64.63. What is the difference between the Net enrolment rate(%) of East Asia (all income levels) in 2004 and the Net enrolment rate(%) of Middle East & North Africa (developing only) in 2008?
Offer a terse response. -5.72. What is the difference between the Net enrolment rate(%) of East Asia (all income levels) in 2004 and the Net enrolment rate(%) of Cambodia in 2008?
Make the answer very short. 21.49. What is the difference between the Net enrolment rate(%) in East Asia (all income levels) in 2004 and the Net enrolment rate(%) in United Kingdom in 2008?
Your answer should be very brief. -34.46. What is the difference between the Net enrolment rate(%) of Middle East & North Africa (developing only) in 2004 and the Net enrolment rate(%) of Cambodia in 2008?
Keep it short and to the point. 27.19. What is the difference between the Net enrolment rate(%) of Middle East & North Africa (developing only) in 2004 and the Net enrolment rate(%) of United Kingdom in 2008?
Your response must be concise. -28.75. What is the difference between the Net enrolment rate(%) of Cambodia in 2004 and the Net enrolment rate(%) of United Kingdom in 2008?
Give a very brief answer. -66.8. What is the difference between the Net enrolment rate(%) of East Asia (all income levels) in 2006 and the Net enrolment rate(%) of Middle East & North Africa (developing only) in 2007?
Give a very brief answer. -1.76. What is the difference between the Net enrolment rate(%) in East Asia (all income levels) in 2006 and the Net enrolment rate(%) in Cambodia in 2007?
Your answer should be compact. 26.93. What is the difference between the Net enrolment rate(%) of East Asia (all income levels) in 2006 and the Net enrolment rate(%) of United Kingdom in 2007?
Your answer should be compact. -29.35. What is the difference between the Net enrolment rate(%) in Middle East & North Africa (developing only) in 2006 and the Net enrolment rate(%) in Cambodia in 2007?
Provide a succinct answer. 29.76. What is the difference between the Net enrolment rate(%) in Middle East & North Africa (developing only) in 2006 and the Net enrolment rate(%) in United Kingdom in 2007?
Ensure brevity in your answer.  -26.51. What is the difference between the Net enrolment rate(%) of Cambodia in 2006 and the Net enrolment rate(%) of United Kingdom in 2007?
Provide a succinct answer. -59.94. What is the difference between the Net enrolment rate(%) in East Asia (all income levels) in 2006 and the Net enrolment rate(%) in Middle East & North Africa (developing only) in 2008?
Provide a succinct answer. -2.78. What is the difference between the Net enrolment rate(%) of East Asia (all income levels) in 2006 and the Net enrolment rate(%) of Cambodia in 2008?
Give a very brief answer. 24.42. What is the difference between the Net enrolment rate(%) in East Asia (all income levels) in 2006 and the Net enrolment rate(%) in United Kingdom in 2008?
Offer a very short reply. -31.53. What is the difference between the Net enrolment rate(%) in Middle East & North Africa (developing only) in 2006 and the Net enrolment rate(%) in Cambodia in 2008?
Keep it short and to the point. 27.25. What is the difference between the Net enrolment rate(%) of Middle East & North Africa (developing only) in 2006 and the Net enrolment rate(%) of United Kingdom in 2008?
Your answer should be very brief. -28.69. What is the difference between the Net enrolment rate(%) of Cambodia in 2006 and the Net enrolment rate(%) of United Kingdom in 2008?
Keep it short and to the point. -62.12. What is the difference between the Net enrolment rate(%) of East Asia (all income levels) in 2007 and the Net enrolment rate(%) of Middle East & North Africa (developing only) in 2008?
Keep it short and to the point. 0.48. What is the difference between the Net enrolment rate(%) of East Asia (all income levels) in 2007 and the Net enrolment rate(%) of Cambodia in 2008?
Ensure brevity in your answer.  27.68. What is the difference between the Net enrolment rate(%) in East Asia (all income levels) in 2007 and the Net enrolment rate(%) in United Kingdom in 2008?
Provide a short and direct response. -28.27. What is the difference between the Net enrolment rate(%) of Middle East & North Africa (developing only) in 2007 and the Net enrolment rate(%) of Cambodia in 2008?
Keep it short and to the point. 26.18. What is the difference between the Net enrolment rate(%) in Middle East & North Africa (developing only) in 2007 and the Net enrolment rate(%) in United Kingdom in 2008?
Give a very brief answer. -29.76. What is the difference between the Net enrolment rate(%) in Cambodia in 2007 and the Net enrolment rate(%) in United Kingdom in 2008?
Your answer should be compact. -58.45. What is the average Net enrolment rate(%) of East Asia (all income levels) per year?
Your answer should be very brief. 60.59. What is the average Net enrolment rate(%) of Middle East & North Africa (developing only) per year?
Your response must be concise. 63.85. What is the average Net enrolment rate(%) in Cambodia per year?
Provide a short and direct response. 26.67. What is the average Net enrolment rate(%) in United Kingdom per year?
Keep it short and to the point. 94.16. In the year 2000, what is the difference between the Net enrolment rate(%) of East Asia (all income levels) and Net enrolment rate(%) of Middle East & North Africa (developing only)?
Provide a succinct answer. -4.53. In the year 2000, what is the difference between the Net enrolment rate(%) in East Asia (all income levels) and Net enrolment rate(%) in Cambodia?
Offer a very short reply. 41.19. In the year 2000, what is the difference between the Net enrolment rate(%) of East Asia (all income levels) and Net enrolment rate(%) of United Kingdom?
Offer a very short reply. -37.84. In the year 2000, what is the difference between the Net enrolment rate(%) in Middle East & North Africa (developing only) and Net enrolment rate(%) in Cambodia?
Make the answer very short. 45.72. In the year 2000, what is the difference between the Net enrolment rate(%) of Middle East & North Africa (developing only) and Net enrolment rate(%) of United Kingdom?
Your answer should be very brief. -33.31. In the year 2000, what is the difference between the Net enrolment rate(%) in Cambodia and Net enrolment rate(%) in United Kingdom?
Offer a very short reply. -79.03. In the year 2001, what is the difference between the Net enrolment rate(%) in East Asia (all income levels) and Net enrolment rate(%) in Middle East & North Africa (developing only)?
Your answer should be compact. -5.34. In the year 2001, what is the difference between the Net enrolment rate(%) of East Asia (all income levels) and Net enrolment rate(%) of Cambodia?
Offer a terse response. 40.16. In the year 2001, what is the difference between the Net enrolment rate(%) in East Asia (all income levels) and Net enrolment rate(%) in United Kingdom?
Provide a succinct answer. -37.94. In the year 2001, what is the difference between the Net enrolment rate(%) in Middle East & North Africa (developing only) and Net enrolment rate(%) in Cambodia?
Provide a short and direct response. 45.5. In the year 2001, what is the difference between the Net enrolment rate(%) of Middle East & North Africa (developing only) and Net enrolment rate(%) of United Kingdom?
Give a very brief answer. -32.6. In the year 2001, what is the difference between the Net enrolment rate(%) in Cambodia and Net enrolment rate(%) in United Kingdom?
Provide a short and direct response. -78.09. In the year 2002, what is the difference between the Net enrolment rate(%) in East Asia (all income levels) and Net enrolment rate(%) in Middle East & North Africa (developing only)?
Ensure brevity in your answer.  -5.96. In the year 2002, what is the difference between the Net enrolment rate(%) of East Asia (all income levels) and Net enrolment rate(%) of Cambodia?
Your answer should be compact. 34.96. In the year 2002, what is the difference between the Net enrolment rate(%) in East Asia (all income levels) and Net enrolment rate(%) in United Kingdom?
Your answer should be compact. -38.46. In the year 2002, what is the difference between the Net enrolment rate(%) in Middle East & North Africa (developing only) and Net enrolment rate(%) in Cambodia?
Offer a very short reply. 40.92. In the year 2002, what is the difference between the Net enrolment rate(%) in Middle East & North Africa (developing only) and Net enrolment rate(%) in United Kingdom?
Provide a short and direct response. -32.5. In the year 2002, what is the difference between the Net enrolment rate(%) of Cambodia and Net enrolment rate(%) of United Kingdom?
Ensure brevity in your answer.  -73.42. In the year 2003, what is the difference between the Net enrolment rate(%) in East Asia (all income levels) and Net enrolment rate(%) in Middle East & North Africa (developing only)?
Give a very brief answer. -5.84. In the year 2003, what is the difference between the Net enrolment rate(%) in East Asia (all income levels) and Net enrolment rate(%) in Cambodia?
Your response must be concise. 32.04. In the year 2003, what is the difference between the Net enrolment rate(%) of East Asia (all income levels) and Net enrolment rate(%) of United Kingdom?
Provide a succinct answer. -36.96. In the year 2003, what is the difference between the Net enrolment rate(%) of Middle East & North Africa (developing only) and Net enrolment rate(%) of Cambodia?
Your answer should be very brief. 37.88. In the year 2003, what is the difference between the Net enrolment rate(%) in Middle East & North Africa (developing only) and Net enrolment rate(%) in United Kingdom?
Provide a short and direct response. -31.12. In the year 2003, what is the difference between the Net enrolment rate(%) in Cambodia and Net enrolment rate(%) in United Kingdom?
Ensure brevity in your answer.  -69. In the year 2004, what is the difference between the Net enrolment rate(%) of East Asia (all income levels) and Net enrolment rate(%) of Middle East & North Africa (developing only)?
Your answer should be compact. -5.7. In the year 2004, what is the difference between the Net enrolment rate(%) of East Asia (all income levels) and Net enrolment rate(%) of Cambodia?
Give a very brief answer. 32.35. In the year 2004, what is the difference between the Net enrolment rate(%) in East Asia (all income levels) and Net enrolment rate(%) in United Kingdom?
Ensure brevity in your answer.  -35.24. In the year 2004, what is the difference between the Net enrolment rate(%) in Middle East & North Africa (developing only) and Net enrolment rate(%) in Cambodia?
Provide a short and direct response. 38.05. In the year 2004, what is the difference between the Net enrolment rate(%) of Middle East & North Africa (developing only) and Net enrolment rate(%) of United Kingdom?
Ensure brevity in your answer.  -29.54. In the year 2004, what is the difference between the Net enrolment rate(%) in Cambodia and Net enrolment rate(%) in United Kingdom?
Make the answer very short. -67.59. In the year 2006, what is the difference between the Net enrolment rate(%) of East Asia (all income levels) and Net enrolment rate(%) of Middle East & North Africa (developing only)?
Your answer should be compact. -2.84. In the year 2006, what is the difference between the Net enrolment rate(%) of East Asia (all income levels) and Net enrolment rate(%) of Cambodia?
Ensure brevity in your answer.  30.59. In the year 2006, what is the difference between the Net enrolment rate(%) in East Asia (all income levels) and Net enrolment rate(%) in United Kingdom?
Provide a succinct answer. -29.97. In the year 2006, what is the difference between the Net enrolment rate(%) of Middle East & North Africa (developing only) and Net enrolment rate(%) of Cambodia?
Provide a succinct answer. 33.43. In the year 2006, what is the difference between the Net enrolment rate(%) of Middle East & North Africa (developing only) and Net enrolment rate(%) of United Kingdom?
Ensure brevity in your answer.  -27.13. In the year 2006, what is the difference between the Net enrolment rate(%) in Cambodia and Net enrolment rate(%) in United Kingdom?
Provide a succinct answer. -60.56. In the year 2007, what is the difference between the Net enrolment rate(%) in East Asia (all income levels) and Net enrolment rate(%) in Middle East & North Africa (developing only)?
Offer a very short reply. 1.5. In the year 2007, what is the difference between the Net enrolment rate(%) in East Asia (all income levels) and Net enrolment rate(%) in Cambodia?
Your answer should be very brief. 30.19. In the year 2007, what is the difference between the Net enrolment rate(%) of East Asia (all income levels) and Net enrolment rate(%) of United Kingdom?
Your answer should be very brief. -26.09. In the year 2007, what is the difference between the Net enrolment rate(%) in Middle East & North Africa (developing only) and Net enrolment rate(%) in Cambodia?
Your response must be concise. 28.69. In the year 2007, what is the difference between the Net enrolment rate(%) in Middle East & North Africa (developing only) and Net enrolment rate(%) in United Kingdom?
Give a very brief answer. -27.58. In the year 2007, what is the difference between the Net enrolment rate(%) in Cambodia and Net enrolment rate(%) in United Kingdom?
Ensure brevity in your answer.  -56.28. In the year 2008, what is the difference between the Net enrolment rate(%) in East Asia (all income levels) and Net enrolment rate(%) in Middle East & North Africa (developing only)?
Provide a short and direct response. 2.65. In the year 2008, what is the difference between the Net enrolment rate(%) of East Asia (all income levels) and Net enrolment rate(%) of Cambodia?
Offer a very short reply. 29.85. In the year 2008, what is the difference between the Net enrolment rate(%) of East Asia (all income levels) and Net enrolment rate(%) of United Kingdom?
Ensure brevity in your answer.  -26.1. In the year 2008, what is the difference between the Net enrolment rate(%) of Middle East & North Africa (developing only) and Net enrolment rate(%) of Cambodia?
Offer a terse response. 27.2. In the year 2008, what is the difference between the Net enrolment rate(%) of Middle East & North Africa (developing only) and Net enrolment rate(%) of United Kingdom?
Ensure brevity in your answer.  -28.74. In the year 2008, what is the difference between the Net enrolment rate(%) of Cambodia and Net enrolment rate(%) of United Kingdom?
Keep it short and to the point. -55.94. What is the ratio of the Net enrolment rate(%) of Middle East & North Africa (developing only) in 2000 to that in 2001?
Make the answer very short. 0.98. What is the ratio of the Net enrolment rate(%) in Cambodia in 2000 to that in 2001?
Ensure brevity in your answer.  0.92. What is the ratio of the Net enrolment rate(%) of United Kingdom in 2000 to that in 2001?
Your answer should be compact. 1. What is the ratio of the Net enrolment rate(%) in Middle East & North Africa (developing only) in 2000 to that in 2002?
Make the answer very short. 0.97. What is the ratio of the Net enrolment rate(%) of Cambodia in 2000 to that in 2002?
Give a very brief answer. 0.7. What is the ratio of the Net enrolment rate(%) of United Kingdom in 2000 to that in 2002?
Ensure brevity in your answer.  0.99. What is the ratio of the Net enrolment rate(%) in East Asia (all income levels) in 2000 to that in 2003?
Give a very brief answer. 0.97. What is the ratio of the Net enrolment rate(%) of Middle East & North Africa (developing only) in 2000 to that in 2003?
Ensure brevity in your answer.  0.95. What is the ratio of the Net enrolment rate(%) of Cambodia in 2000 to that in 2003?
Make the answer very short. 0.58. What is the ratio of the Net enrolment rate(%) in East Asia (all income levels) in 2000 to that in 2004?
Provide a short and direct response. 0.95. What is the ratio of the Net enrolment rate(%) of Middle East & North Africa (developing only) in 2000 to that in 2004?
Give a very brief answer. 0.93. What is the ratio of the Net enrolment rate(%) in Cambodia in 2000 to that in 2004?
Offer a very short reply. 0.56. What is the ratio of the Net enrolment rate(%) of United Kingdom in 2000 to that in 2004?
Keep it short and to the point. 0.99. What is the ratio of the Net enrolment rate(%) of East Asia (all income levels) in 2000 to that in 2006?
Offer a very short reply. 0.9. What is the ratio of the Net enrolment rate(%) in Middle East & North Africa (developing only) in 2000 to that in 2006?
Your answer should be very brief. 0.93. What is the ratio of the Net enrolment rate(%) of Cambodia in 2000 to that in 2006?
Ensure brevity in your answer.  0.48. What is the ratio of the Net enrolment rate(%) in United Kingdom in 2000 to that in 2006?
Provide a succinct answer. 1.02. What is the ratio of the Net enrolment rate(%) of East Asia (all income levels) in 2000 to that in 2007?
Offer a very short reply. 0.86. What is the ratio of the Net enrolment rate(%) of Middle East & North Africa (developing only) in 2000 to that in 2007?
Provide a short and direct response. 0.95. What is the ratio of the Net enrolment rate(%) in Cambodia in 2000 to that in 2007?
Provide a short and direct response. 0.43. What is the ratio of the Net enrolment rate(%) in United Kingdom in 2000 to that in 2007?
Offer a terse response. 1.03. What is the ratio of the Net enrolment rate(%) in East Asia (all income levels) in 2000 to that in 2008?
Keep it short and to the point. 0.83. What is the ratio of the Net enrolment rate(%) of Middle East & North Africa (developing only) in 2000 to that in 2008?
Your response must be concise. 0.93. What is the ratio of the Net enrolment rate(%) in Cambodia in 2000 to that in 2008?
Provide a succinct answer. 0.4. What is the ratio of the Net enrolment rate(%) in East Asia (all income levels) in 2001 to that in 2002?
Your response must be concise. 1. What is the ratio of the Net enrolment rate(%) of Cambodia in 2001 to that in 2002?
Give a very brief answer. 0.75. What is the ratio of the Net enrolment rate(%) of United Kingdom in 2001 to that in 2002?
Ensure brevity in your answer.  0.99. What is the ratio of the Net enrolment rate(%) of East Asia (all income levels) in 2001 to that in 2003?
Provide a succinct answer. 0.97. What is the ratio of the Net enrolment rate(%) of Middle East & North Africa (developing only) in 2001 to that in 2003?
Keep it short and to the point. 0.97. What is the ratio of the Net enrolment rate(%) of Cambodia in 2001 to that in 2003?
Make the answer very short. 0.63. What is the ratio of the Net enrolment rate(%) in United Kingdom in 2001 to that in 2003?
Ensure brevity in your answer.  0.99. What is the ratio of the Net enrolment rate(%) of East Asia (all income levels) in 2001 to that in 2004?
Your answer should be very brief. 0.95. What is the ratio of the Net enrolment rate(%) in Middle East & North Africa (developing only) in 2001 to that in 2004?
Provide a short and direct response. 0.95. What is the ratio of the Net enrolment rate(%) in Cambodia in 2001 to that in 2004?
Your response must be concise. 0.61. What is the ratio of the Net enrolment rate(%) in East Asia (all income levels) in 2001 to that in 2006?
Your answer should be compact. 0.91. What is the ratio of the Net enrolment rate(%) in Middle East & North Africa (developing only) in 2001 to that in 2006?
Your answer should be compact. 0.95. What is the ratio of the Net enrolment rate(%) in Cambodia in 2001 to that in 2006?
Make the answer very short. 0.52. What is the ratio of the Net enrolment rate(%) in United Kingdom in 2001 to that in 2006?
Your response must be concise. 1.02. What is the ratio of the Net enrolment rate(%) of East Asia (all income levels) in 2001 to that in 2007?
Your answer should be compact. 0.86. What is the ratio of the Net enrolment rate(%) in Middle East & North Africa (developing only) in 2001 to that in 2007?
Keep it short and to the point. 0.97. What is the ratio of the Net enrolment rate(%) in Cambodia in 2001 to that in 2007?
Give a very brief answer. 0.47. What is the ratio of the Net enrolment rate(%) in United Kingdom in 2001 to that in 2007?
Make the answer very short. 1.03. What is the ratio of the Net enrolment rate(%) of East Asia (all income levels) in 2001 to that in 2008?
Your response must be concise. 0.83. What is the ratio of the Net enrolment rate(%) of Middle East & North Africa (developing only) in 2001 to that in 2008?
Your answer should be compact. 0.95. What is the ratio of the Net enrolment rate(%) in Cambodia in 2001 to that in 2008?
Keep it short and to the point. 0.44. What is the ratio of the Net enrolment rate(%) of United Kingdom in 2001 to that in 2008?
Provide a succinct answer. 1.01. What is the ratio of the Net enrolment rate(%) of East Asia (all income levels) in 2002 to that in 2003?
Make the answer very short. 0.98. What is the ratio of the Net enrolment rate(%) of Middle East & North Africa (developing only) in 2002 to that in 2003?
Your answer should be compact. 0.98. What is the ratio of the Net enrolment rate(%) of Cambodia in 2002 to that in 2003?
Your answer should be very brief. 0.84. What is the ratio of the Net enrolment rate(%) in East Asia (all income levels) in 2002 to that in 2004?
Keep it short and to the point. 0.96. What is the ratio of the Net enrolment rate(%) in Middle East & North Africa (developing only) in 2002 to that in 2004?
Offer a very short reply. 0.96. What is the ratio of the Net enrolment rate(%) of Cambodia in 2002 to that in 2004?
Offer a very short reply. 0.81. What is the ratio of the Net enrolment rate(%) in United Kingdom in 2002 to that in 2004?
Give a very brief answer. 1.01. What is the ratio of the Net enrolment rate(%) in East Asia (all income levels) in 2002 to that in 2006?
Give a very brief answer. 0.91. What is the ratio of the Net enrolment rate(%) in Middle East & North Africa (developing only) in 2002 to that in 2006?
Make the answer very short. 0.96. What is the ratio of the Net enrolment rate(%) in Cambodia in 2002 to that in 2006?
Provide a short and direct response. 0.69. What is the ratio of the Net enrolment rate(%) of United Kingdom in 2002 to that in 2006?
Give a very brief answer. 1.03. What is the ratio of the Net enrolment rate(%) of East Asia (all income levels) in 2002 to that in 2007?
Make the answer very short. 0.87. What is the ratio of the Net enrolment rate(%) of Middle East & North Africa (developing only) in 2002 to that in 2007?
Your answer should be very brief. 0.98. What is the ratio of the Net enrolment rate(%) in Cambodia in 2002 to that in 2007?
Provide a succinct answer. 0.62. What is the ratio of the Net enrolment rate(%) in United Kingdom in 2002 to that in 2007?
Your answer should be compact. 1.04. What is the ratio of the Net enrolment rate(%) of East Asia (all income levels) in 2002 to that in 2008?
Keep it short and to the point. 0.84. What is the ratio of the Net enrolment rate(%) in Middle East & North Africa (developing only) in 2002 to that in 2008?
Give a very brief answer. 0.96. What is the ratio of the Net enrolment rate(%) of Cambodia in 2002 to that in 2008?
Your answer should be compact. 0.58. What is the ratio of the Net enrolment rate(%) of United Kingdom in 2002 to that in 2008?
Ensure brevity in your answer.  1.01. What is the ratio of the Net enrolment rate(%) of East Asia (all income levels) in 2003 to that in 2004?
Make the answer very short. 0.98. What is the ratio of the Net enrolment rate(%) of Middle East & North Africa (developing only) in 2003 to that in 2004?
Your answer should be compact. 0.98. What is the ratio of the Net enrolment rate(%) in Cambodia in 2003 to that in 2004?
Your answer should be compact. 0.96. What is the ratio of the Net enrolment rate(%) in East Asia (all income levels) in 2003 to that in 2006?
Give a very brief answer. 0.93. What is the ratio of the Net enrolment rate(%) of Middle East & North Africa (developing only) in 2003 to that in 2006?
Provide a short and direct response. 0.98. What is the ratio of the Net enrolment rate(%) of Cambodia in 2003 to that in 2006?
Provide a succinct answer. 0.82. What is the ratio of the Net enrolment rate(%) in United Kingdom in 2003 to that in 2006?
Offer a very short reply. 1.03. What is the ratio of the Net enrolment rate(%) of East Asia (all income levels) in 2003 to that in 2007?
Offer a very short reply. 0.89. What is the ratio of the Net enrolment rate(%) in Cambodia in 2003 to that in 2007?
Your answer should be very brief. 0.74. What is the ratio of the Net enrolment rate(%) in United Kingdom in 2003 to that in 2007?
Provide a succinct answer. 1.04. What is the ratio of the Net enrolment rate(%) in East Asia (all income levels) in 2003 to that in 2008?
Keep it short and to the point. 0.86. What is the ratio of the Net enrolment rate(%) in Middle East & North Africa (developing only) in 2003 to that in 2008?
Keep it short and to the point. 0.98. What is the ratio of the Net enrolment rate(%) of Cambodia in 2003 to that in 2008?
Ensure brevity in your answer.  0.69. What is the ratio of the Net enrolment rate(%) of United Kingdom in 2003 to that in 2008?
Make the answer very short. 1.01. What is the ratio of the Net enrolment rate(%) in East Asia (all income levels) in 2004 to that in 2006?
Your answer should be very brief. 0.95. What is the ratio of the Net enrolment rate(%) of Middle East & North Africa (developing only) in 2004 to that in 2006?
Your answer should be very brief. 1. What is the ratio of the Net enrolment rate(%) in Cambodia in 2004 to that in 2006?
Offer a very short reply. 0.85. What is the ratio of the Net enrolment rate(%) in United Kingdom in 2004 to that in 2006?
Your response must be concise. 1.03. What is the ratio of the Net enrolment rate(%) of East Asia (all income levels) in 2004 to that in 2007?
Your response must be concise. 0.91. What is the ratio of the Net enrolment rate(%) in Middle East & North Africa (developing only) in 2004 to that in 2007?
Keep it short and to the point. 1.02. What is the ratio of the Net enrolment rate(%) of Cambodia in 2004 to that in 2007?
Your answer should be very brief. 0.77. What is the ratio of the Net enrolment rate(%) in United Kingdom in 2004 to that in 2007?
Offer a very short reply. 1.03. What is the ratio of the Net enrolment rate(%) of East Asia (all income levels) in 2004 to that in 2008?
Offer a very short reply. 0.88. What is the ratio of the Net enrolment rate(%) in Middle East & North Africa (developing only) in 2004 to that in 2008?
Make the answer very short. 1. What is the ratio of the Net enrolment rate(%) in Cambodia in 2004 to that in 2008?
Give a very brief answer. 0.72. What is the ratio of the Net enrolment rate(%) in United Kingdom in 2004 to that in 2008?
Offer a terse response. 1.01. What is the ratio of the Net enrolment rate(%) in East Asia (all income levels) in 2006 to that in 2007?
Provide a succinct answer. 0.95. What is the ratio of the Net enrolment rate(%) of Middle East & North Africa (developing only) in 2006 to that in 2007?
Your answer should be very brief. 1.02. What is the ratio of the Net enrolment rate(%) of Cambodia in 2006 to that in 2007?
Provide a short and direct response. 0.9. What is the ratio of the Net enrolment rate(%) of United Kingdom in 2006 to that in 2007?
Provide a succinct answer. 1.01. What is the ratio of the Net enrolment rate(%) in East Asia (all income levels) in 2006 to that in 2008?
Provide a succinct answer. 0.92. What is the ratio of the Net enrolment rate(%) in Cambodia in 2006 to that in 2008?
Offer a terse response. 0.84. What is the ratio of the Net enrolment rate(%) of United Kingdom in 2006 to that in 2008?
Keep it short and to the point. 0.98. What is the ratio of the Net enrolment rate(%) in East Asia (all income levels) in 2007 to that in 2008?
Provide a short and direct response. 0.97. What is the ratio of the Net enrolment rate(%) in Middle East & North Africa (developing only) in 2007 to that in 2008?
Offer a terse response. 0.98. What is the ratio of the Net enrolment rate(%) in Cambodia in 2007 to that in 2008?
Your answer should be very brief. 0.93. What is the ratio of the Net enrolment rate(%) of United Kingdom in 2007 to that in 2008?
Provide a short and direct response. 0.98. What is the difference between the highest and the second highest Net enrolment rate(%) in East Asia (all income levels)?
Ensure brevity in your answer.  2.17. What is the difference between the highest and the second highest Net enrolment rate(%) of Middle East & North Africa (developing only)?
Offer a terse response. 0.05. What is the difference between the highest and the second highest Net enrolment rate(%) in Cambodia?
Your answer should be compact. 2.51. What is the difference between the highest and the second highest Net enrolment rate(%) of United Kingdom?
Your response must be concise. 0.16. What is the difference between the highest and the lowest Net enrolment rate(%) in East Asia (all income levels)?
Your answer should be very brief. 11.46. What is the difference between the highest and the lowest Net enrolment rate(%) in Middle East & North Africa (developing only)?
Your answer should be very brief. 4.33. What is the difference between the highest and the lowest Net enrolment rate(%) in Cambodia?
Your response must be concise. 22.8. What is the difference between the highest and the lowest Net enrolment rate(%) in United Kingdom?
Make the answer very short. 3.53. 